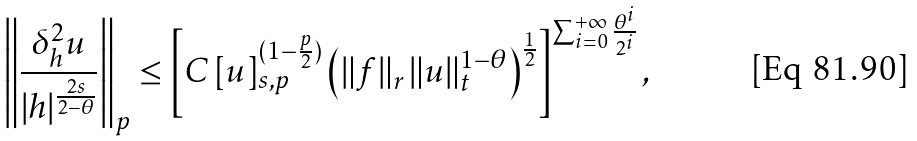Convert formula to latex. <formula><loc_0><loc_0><loc_500><loc_500>\left \| \frac { \delta ^ { 2 } _ { h } u } { | h | ^ { \frac { 2 s } { 2 - \theta } } } \right \| _ { p } \leq \left [ C \, [ u ] _ { s , p } ^ { ( 1 - \frac { p } { 2 } ) } \left ( \| f \| _ { r } \, \| u \| _ { t } ^ { 1 - \theta } \right ) ^ { \frac { 1 } { 2 } } \right ] ^ { \sum _ { i = 0 } ^ { + \infty } \frac { \theta ^ { i } } { 2 ^ { i } } } ,</formula> 